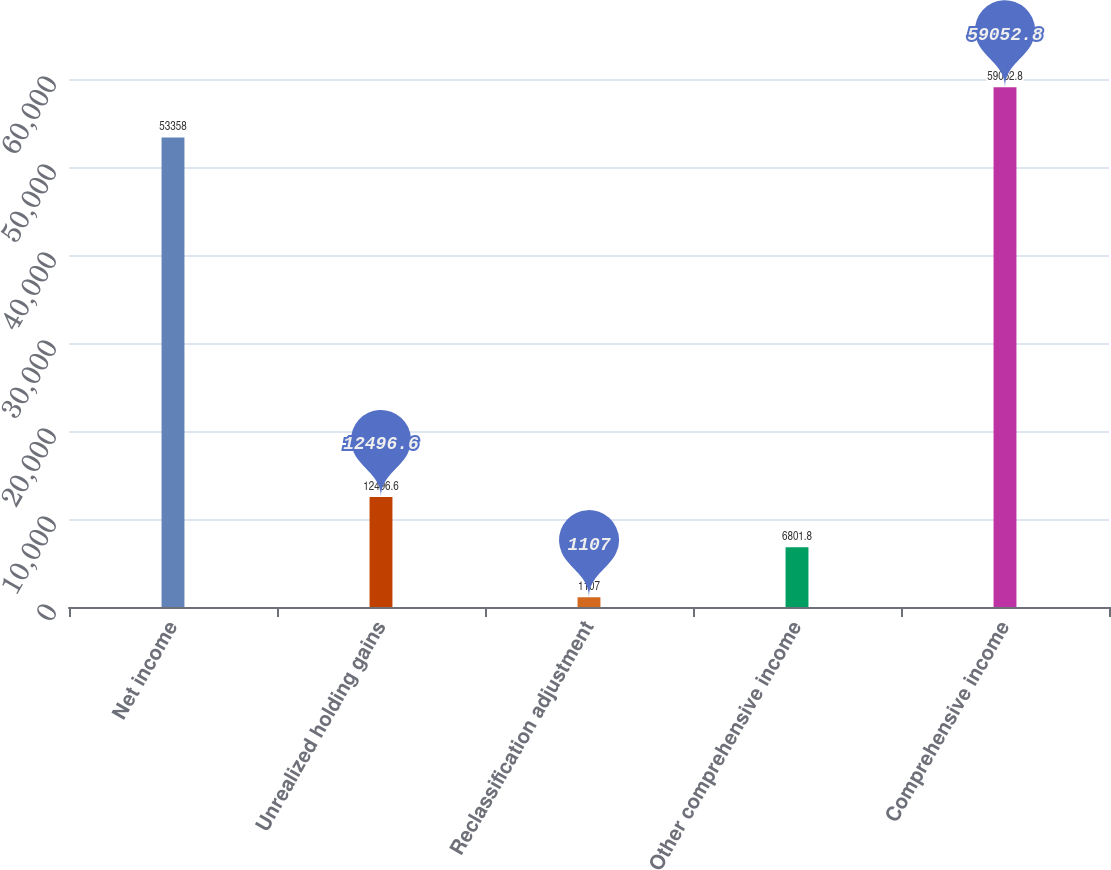Convert chart to OTSL. <chart><loc_0><loc_0><loc_500><loc_500><bar_chart><fcel>Net income<fcel>Unrealized holding gains<fcel>Reclassification adjustment<fcel>Other comprehensive income<fcel>Comprehensive income<nl><fcel>53358<fcel>12496.6<fcel>1107<fcel>6801.8<fcel>59052.8<nl></chart> 